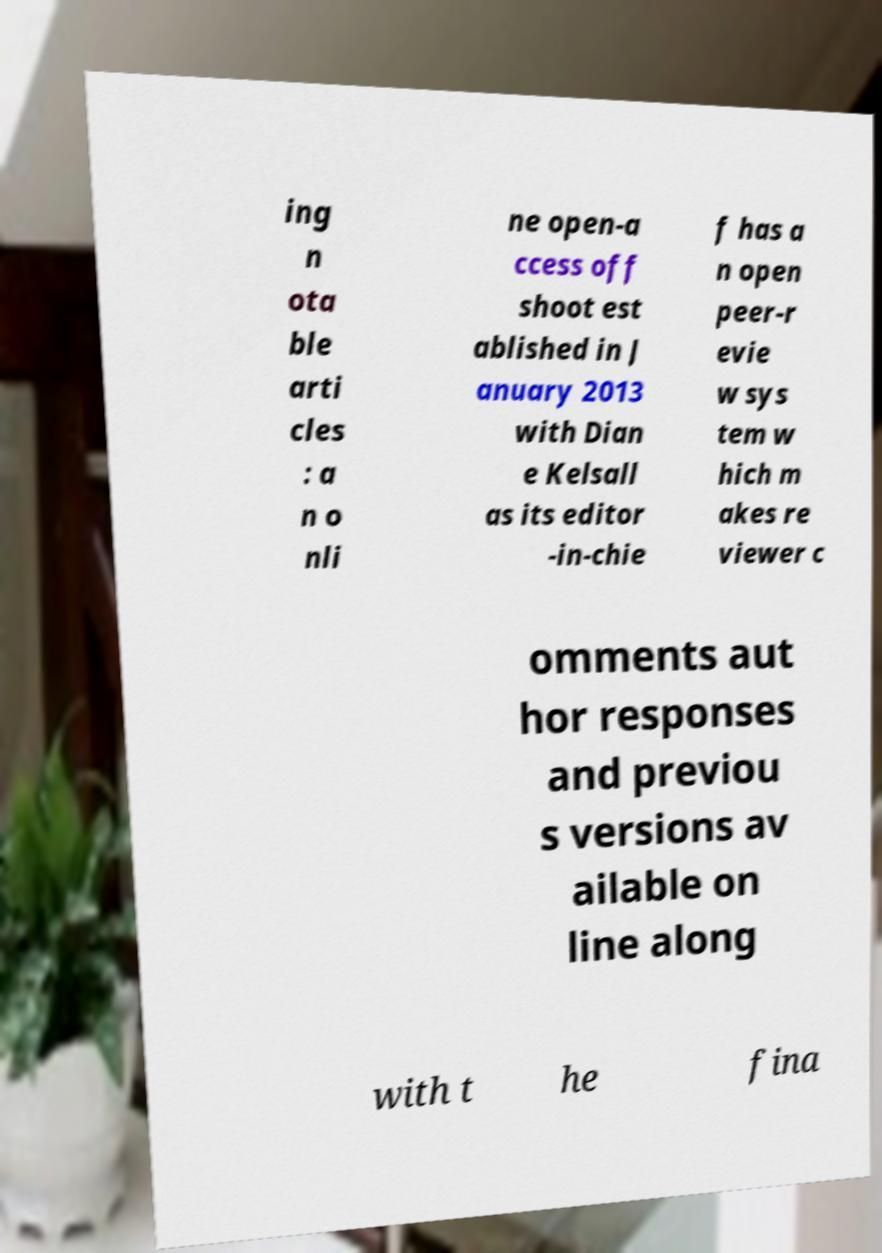Can you accurately transcribe the text from the provided image for me? ing n ota ble arti cles : a n o nli ne open-a ccess off shoot est ablished in J anuary 2013 with Dian e Kelsall as its editor -in-chie f has a n open peer-r evie w sys tem w hich m akes re viewer c omments aut hor responses and previou s versions av ailable on line along with t he fina 